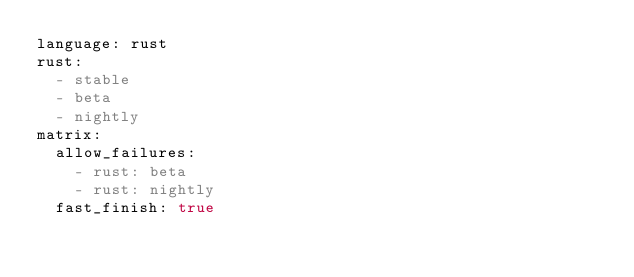Convert code to text. <code><loc_0><loc_0><loc_500><loc_500><_YAML_>language: rust
rust:
  - stable
  - beta
  - nightly
matrix:
  allow_failures:
    - rust: beta
    - rust: nightly
  fast_finish: true
</code> 